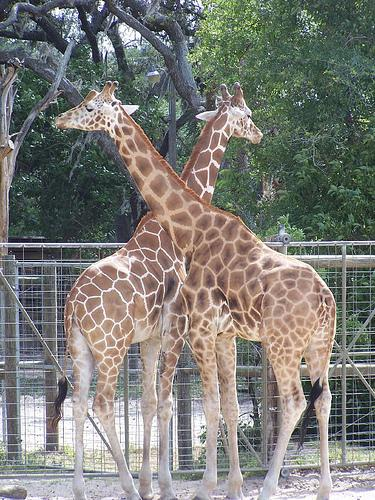Question: how many giraffes are there?
Choices:
A. Three.
B. Two.
C. Four.
D. Nine.
Answer with the letter. Answer: B Question: why is the fence there?
Choices:
A. To keep children in the yard.
B. Safety.
C. Contain giraffes.
D. Contain dog.
Answer with the letter. Answer: C Question: what is behind the giraffes?
Choices:
A. Grass.
B. Sand.
C. Dirt.
D. Fence.
Answer with the letter. Answer: D Question: who is in the picture?
Choices:
A. No one.
B. Twins.
C. Mother.
D. Father.
Answer with the letter. Answer: A Question: what color is the fence?
Choices:
A. Gold.
B. Black.
C. White.
D. Silver.
Answer with the letter. Answer: D Question: what is in green?
Choices:
A. The grass.
B. The frisbee.
C. The shirt.
D. The leaves.
Answer with the letter. Answer: D Question: when is the picture taken?
Choices:
A. Day time.
B. Dusk.
C. Dawn.
D. Midnight.
Answer with the letter. Answer: A Question: where are the trees?
Choices:
A. Foreground.
B. Background.
C. Behind the house.
D. On the roof.
Answer with the letter. Answer: B 